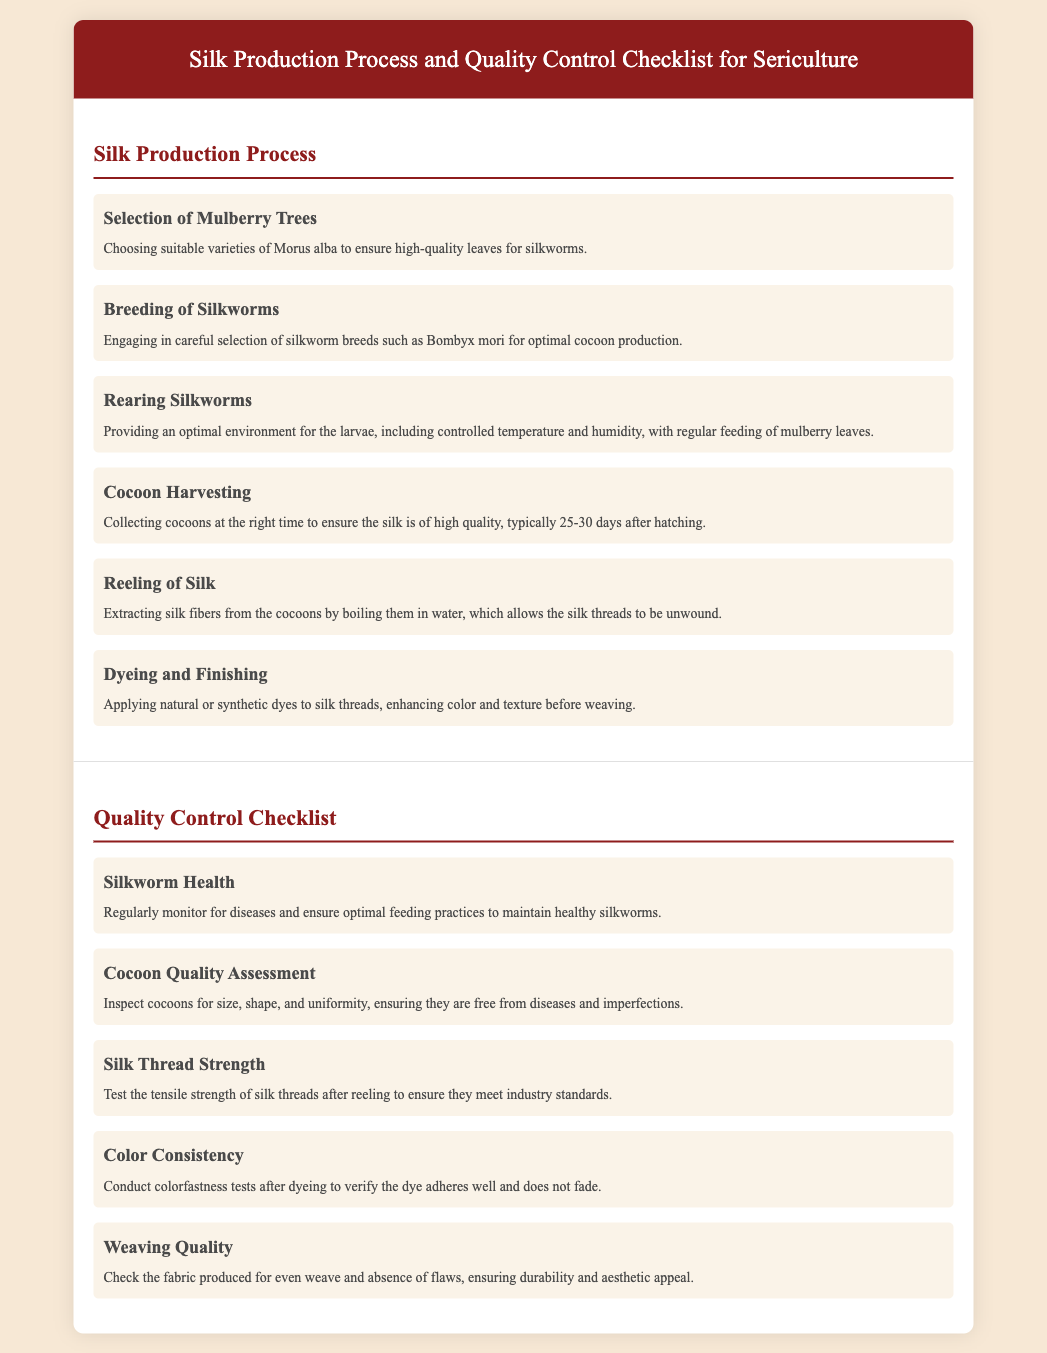what is the first step in the silk production process? The first step mentioned is "Selection of Mulberry Trees," which ensures high-quality leaves for silkworms.
Answer: Selection of Mulberry Trees which silkworm breed is emphasized for optimal cocoon production? The document highlights "Bombyx mori" as the breed used for optimal cocoon production.
Answer: Bombyx mori how long after hatching should cocoons be harvested? The document states that cocoons should be harvested "typically 25-30 days" after hatching for high quality.
Answer: 25-30 days what factor is monitored for silkworms in the quality control checklist? The checklist emphasizes monitoring for "diseases" to maintain healthy silkworms.
Answer: diseases what quality is tested after reeling silk threads? The document indicates that the "tensile strength" of silk threads is tested to meet industry standards.
Answer: tensile strength what should the cocoons be inspected for, according to the quality control guidelines? The cocoons should be inspected for "size, shape, and uniformity" to ensure quality.
Answer: size, shape, and uniformity during dyeing, what test verifies the dye's adherence? The document mentions conducting "colorfastness tests" to verify dye adherence and prevent fading.
Answer: colorfastness tests what is checked to ensure the fabric's quality? The checklist specifies that the fabric must be checked for "even weave and absence of flaws."
Answer: even weave and absence of flaws 